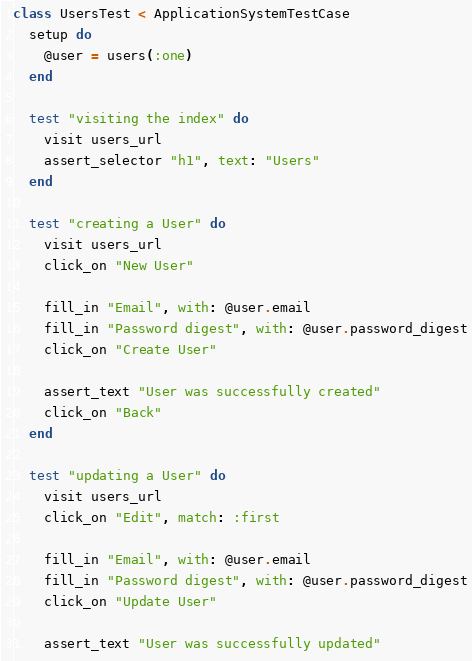Convert code to text. <code><loc_0><loc_0><loc_500><loc_500><_Ruby_>
class UsersTest < ApplicationSystemTestCase
  setup do
    @user = users(:one)
  end

  test "visiting the index" do
    visit users_url
    assert_selector "h1", text: "Users"
  end

  test "creating a User" do
    visit users_url
    click_on "New User"

    fill_in "Email", with: @user.email
    fill_in "Password digest", with: @user.password_digest
    click_on "Create User"

    assert_text "User was successfully created"
    click_on "Back"
  end

  test "updating a User" do
    visit users_url
    click_on "Edit", match: :first

    fill_in "Email", with: @user.email
    fill_in "Password digest", with: @user.password_digest
    click_on "Update User"

    assert_text "User was successfully updated"</code> 